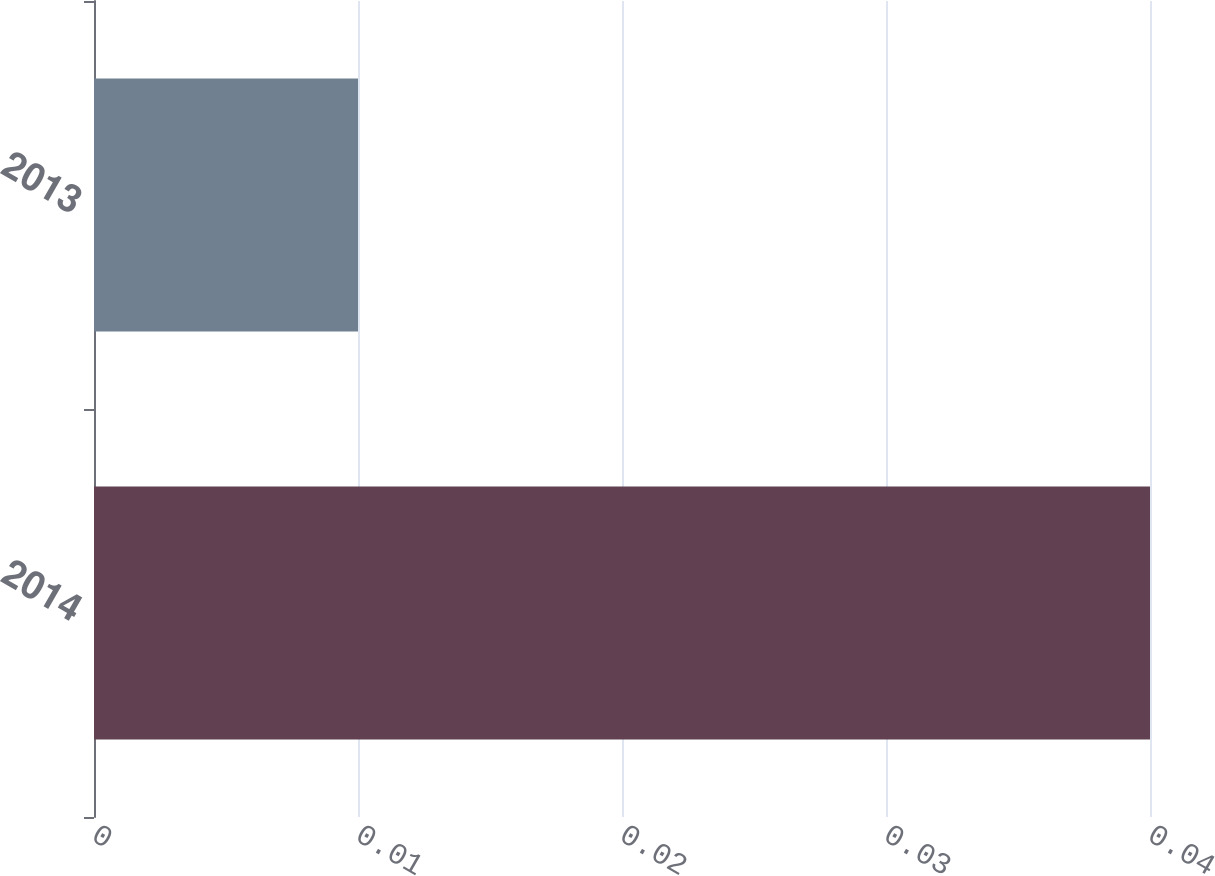<chart> <loc_0><loc_0><loc_500><loc_500><bar_chart><fcel>2014<fcel>2013<nl><fcel>0.04<fcel>0.01<nl></chart> 